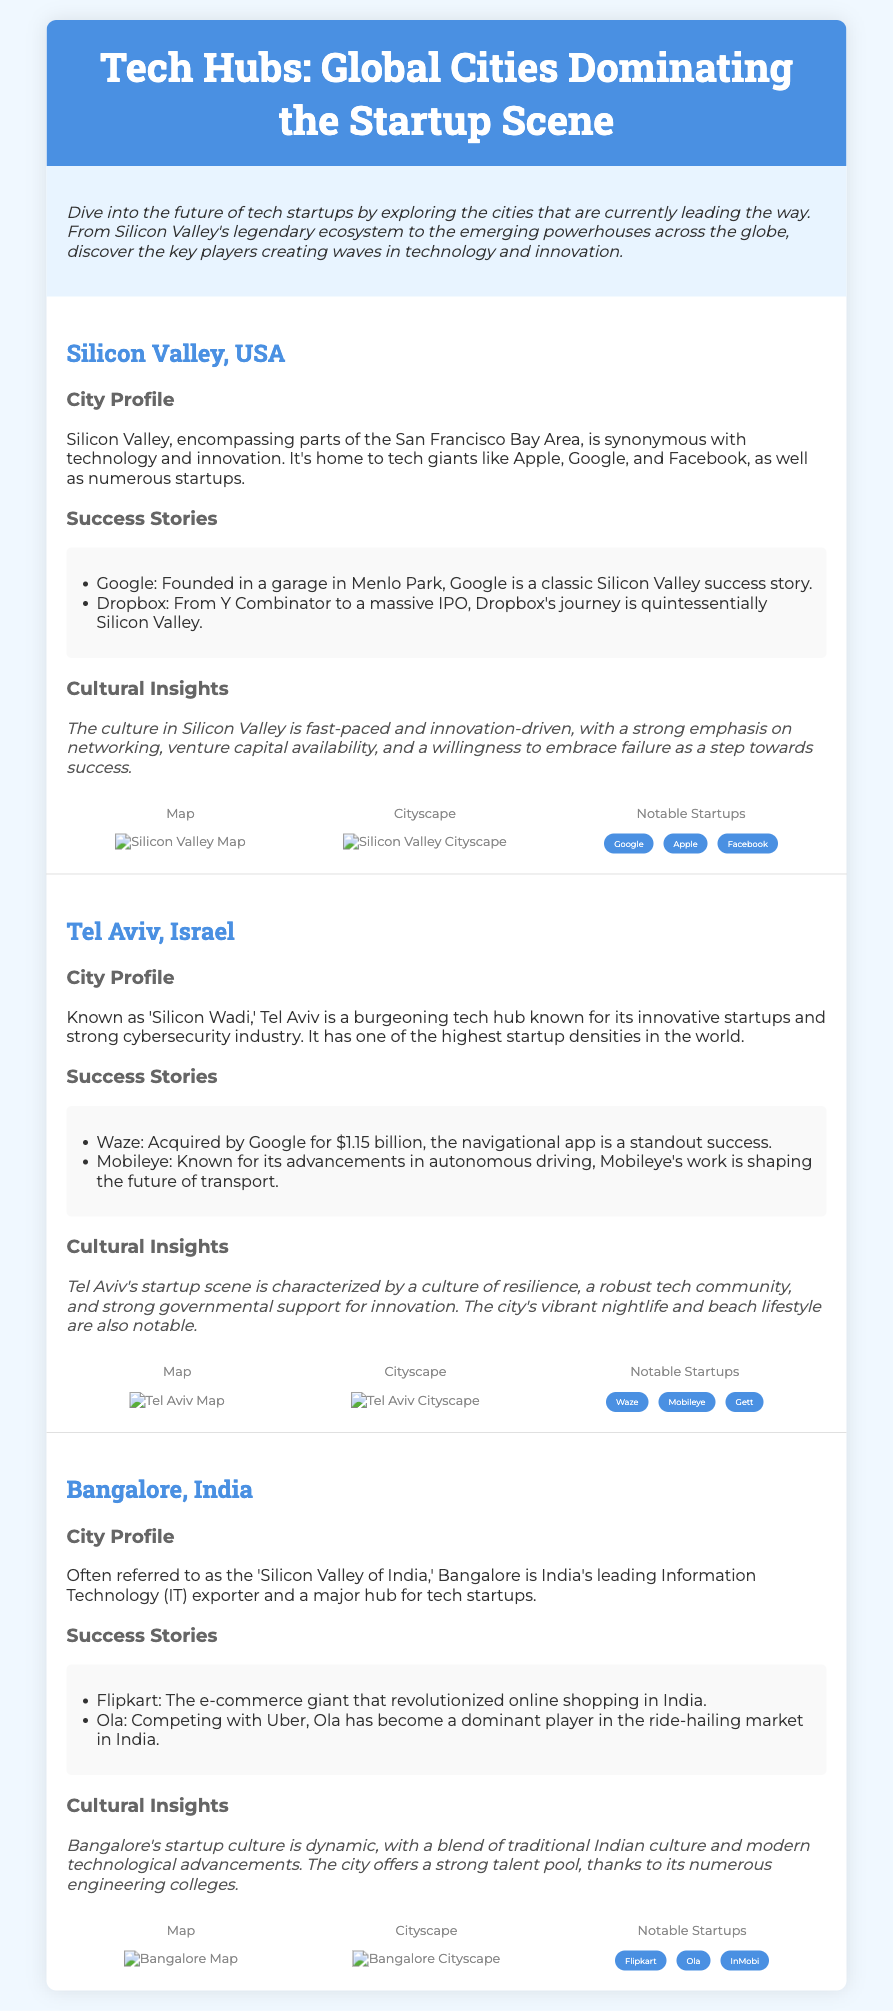What city is known as 'Silicon Wadi'? The document states that Tel Aviv is also referred to as 'Silicon Wadi'.
Answer: Tel Aviv Which city's notable startups include Flipkart and Ola? The document lists Flipkart and Ola under the notable startups for Bangalore.
Answer: Bangalore What significant event is mentioned regarding Waze? Waze is described as having been acquired by Google for $1.15 billion.
Answer: Acquired by Google for $1.15 billion What is the primary focus of the cultural insights section for Silicon Valley? The section emphasizes the fast-paced, innovation-driven culture of Silicon Valley.
Answer: Fast-paced, innovation-driven culture How many startup icons are mentioned for Silicon Valley? Silicon Valley is said to have three notable startup icons listed: Google, Apple, and Facebook.
Answer: Three Which location has the highest startup density in the world? The document indicates that Tel Aviv has one of the highest startup densities in the world.
Answer: Tel Aviv What genre of document is this? The document is identified as a Playbill, focused on tech hubs and startups.
Answer: Playbill What is the primary industry focus for Bangalore? The document mentions that Bangalore is recognized as India's leading Information Technology (IT) exporter.
Answer: Information Technology (IT) exporter Which company started in a garage in Menlo Park? The document specifies that Google was founded in a garage in Menlo Park.
Answer: Google 